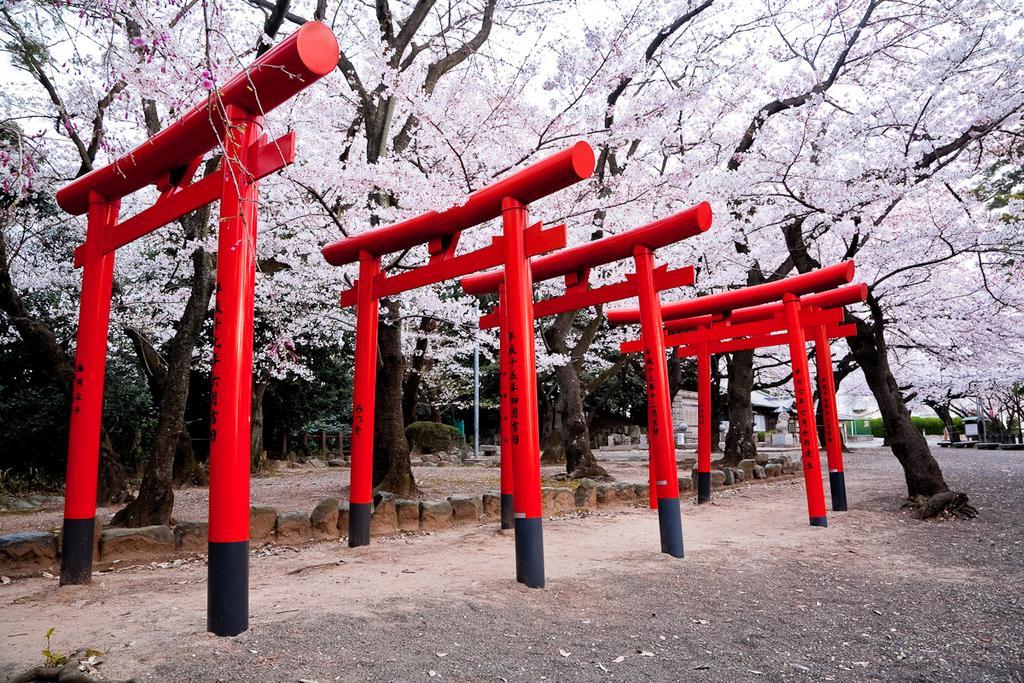Describe this image in one or two sentences. In the center of the image an arch is present. In the background of the image trees are present. In the middle of the image a plant, rocks are there. At the bottom of the image ground is present. 